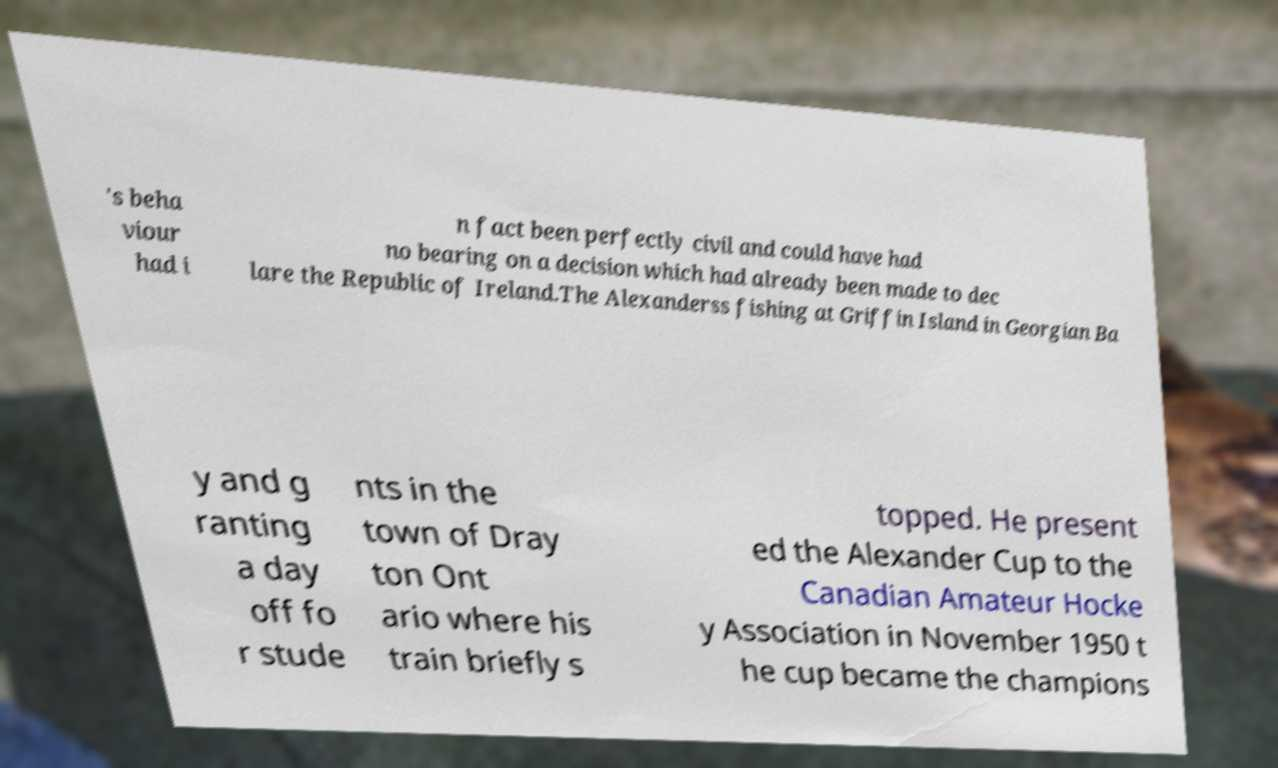Please identify and transcribe the text found in this image. 's beha viour had i n fact been perfectly civil and could have had no bearing on a decision which had already been made to dec lare the Republic of Ireland.The Alexanderss fishing at Griffin Island in Georgian Ba y and g ranting a day off fo r stude nts in the town of Dray ton Ont ario where his train briefly s topped. He present ed the Alexander Cup to the Canadian Amateur Hocke y Association in November 1950 t he cup became the champions 